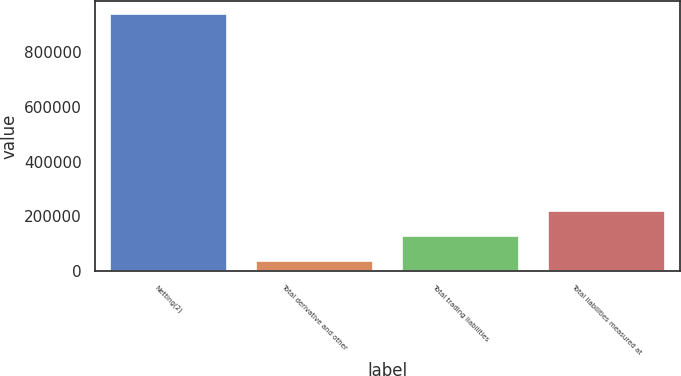Convert chart. <chart><loc_0><loc_0><loc_500><loc_500><bar_chart><fcel>Netting(2)<fcel>Total derivative and other<fcel>Total trading liabilities<fcel>Total liabilities measured at<nl><fcel>941815<fcel>36958<fcel>127444<fcel>217929<nl></chart> 